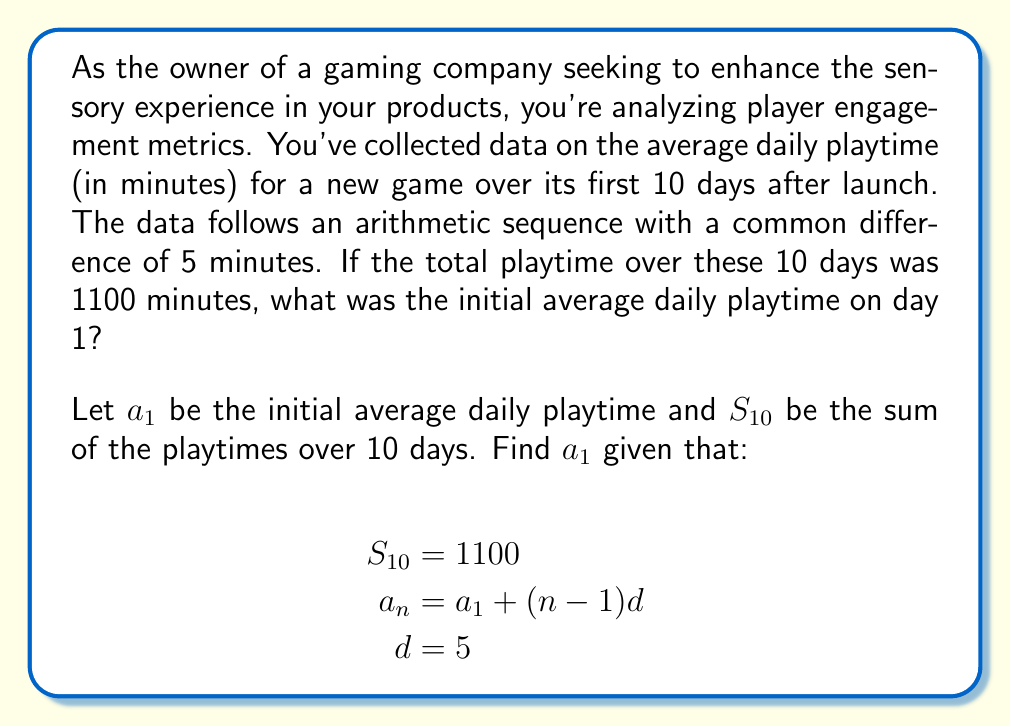Can you solve this math problem? To solve this problem, we'll use the formula for the sum of an arithmetic sequence:

$$S_n = \frac{n}{2}(a_1 + a_n)$$

Where:
- $S_n$ is the sum of the sequence
- $n$ is the number of terms
- $a_1$ is the first term
- $a_n$ is the last term

We know that:
- $S_{10} = 1100$
- $n = 10$
- $d = 5$

We need to express $a_{10}$ in terms of $a_1$:

$$a_{10} = a_1 + (10-1)d = a_1 + 45$$

Now, let's substitute these into our sum formula:

$$1100 = \frac{10}{2}(a_1 + (a_1 + 45))$$

Simplify:

$$1100 = 5(2a_1 + 45)$$
$$1100 = 10a_1 + 225$$

Solve for $a_1$:

$$875 = 10a_1$$
$$a_1 = 87.5$$

Therefore, the initial average daily playtime on day 1 was 87.5 minutes.
Answer: $a_1 = 87.5$ minutes 